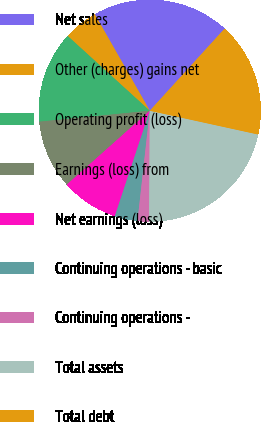Convert chart. <chart><loc_0><loc_0><loc_500><loc_500><pie_chart><fcel>Net sales<fcel>Other (charges) gains net<fcel>Operating profit (loss)<fcel>Earnings (loss) from<fcel>Net earnings (loss)<fcel>Continuing operations - basic<fcel>Continuing operations -<fcel>Total assets<fcel>Total debt<nl><fcel>20.0%<fcel>5.0%<fcel>13.33%<fcel>10.0%<fcel>8.33%<fcel>3.33%<fcel>1.67%<fcel>21.66%<fcel>16.67%<nl></chart> 